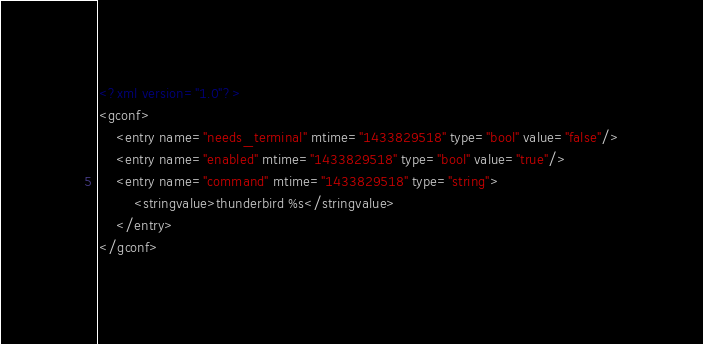<code> <loc_0><loc_0><loc_500><loc_500><_XML_><?xml version="1.0"?>
<gconf>
	<entry name="needs_terminal" mtime="1433829518" type="bool" value="false"/>
	<entry name="enabled" mtime="1433829518" type="bool" value="true"/>
	<entry name="command" mtime="1433829518" type="string">
		<stringvalue>thunderbird %s</stringvalue>
	</entry>
</gconf>
</code> 